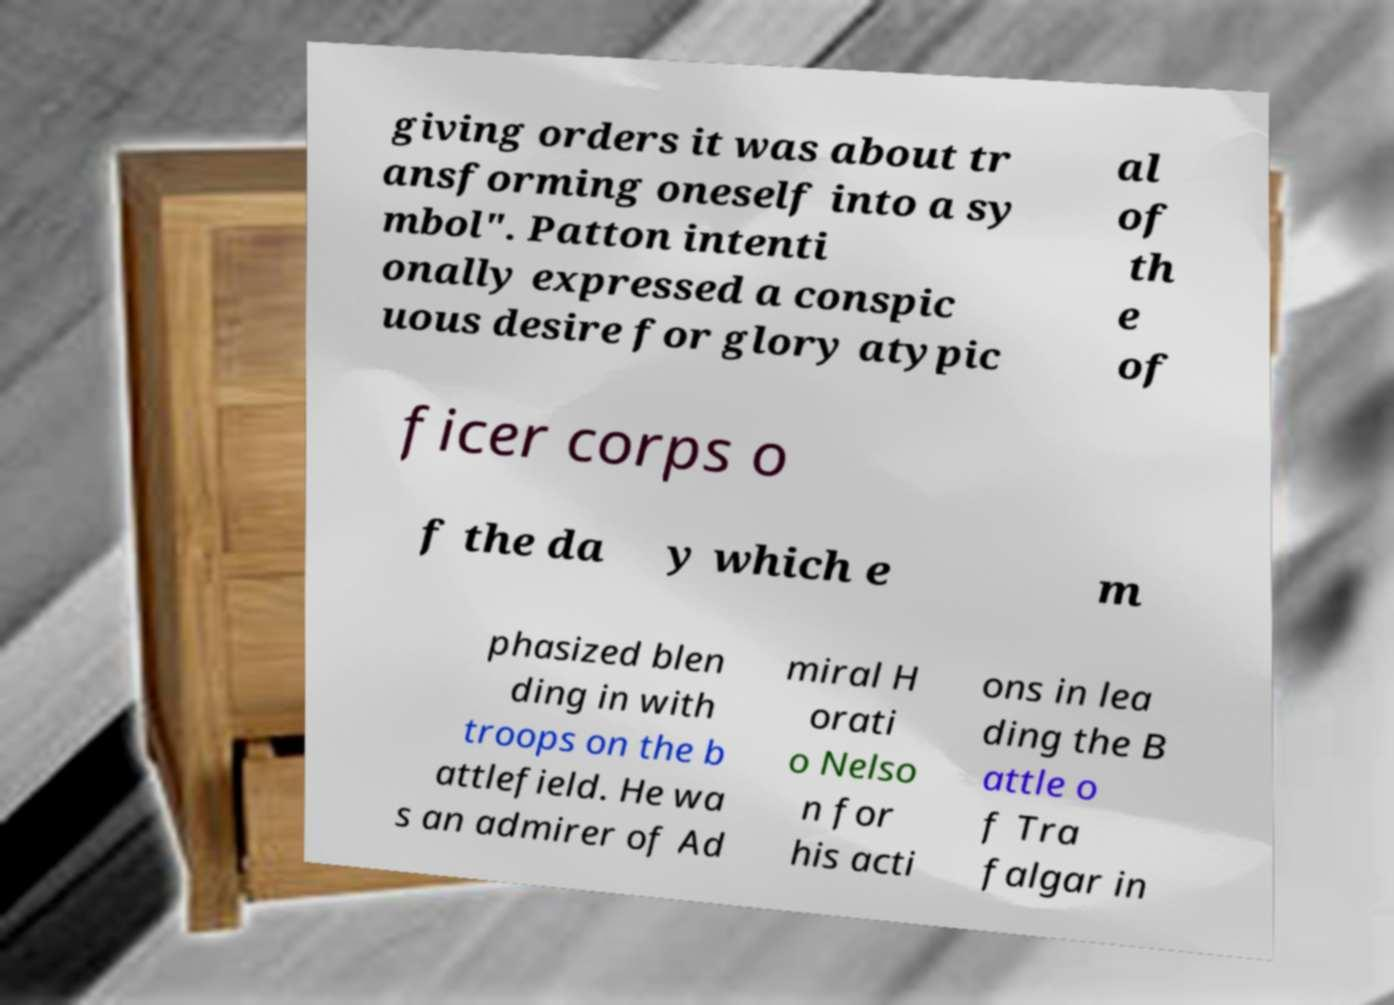For documentation purposes, I need the text within this image transcribed. Could you provide that? giving orders it was about tr ansforming oneself into a sy mbol". Patton intenti onally expressed a conspic uous desire for glory atypic al of th e of ficer corps o f the da y which e m phasized blen ding in with troops on the b attlefield. He wa s an admirer of Ad miral H orati o Nelso n for his acti ons in lea ding the B attle o f Tra falgar in 